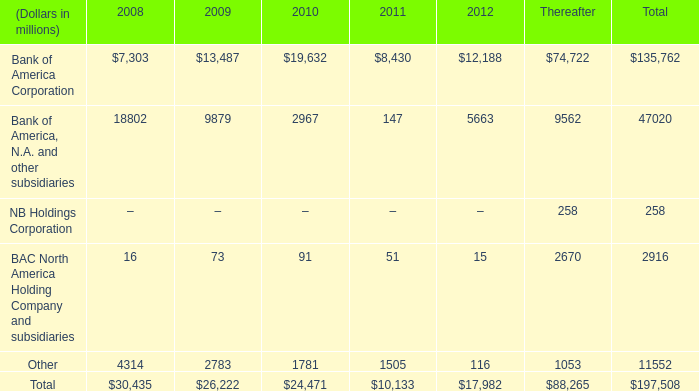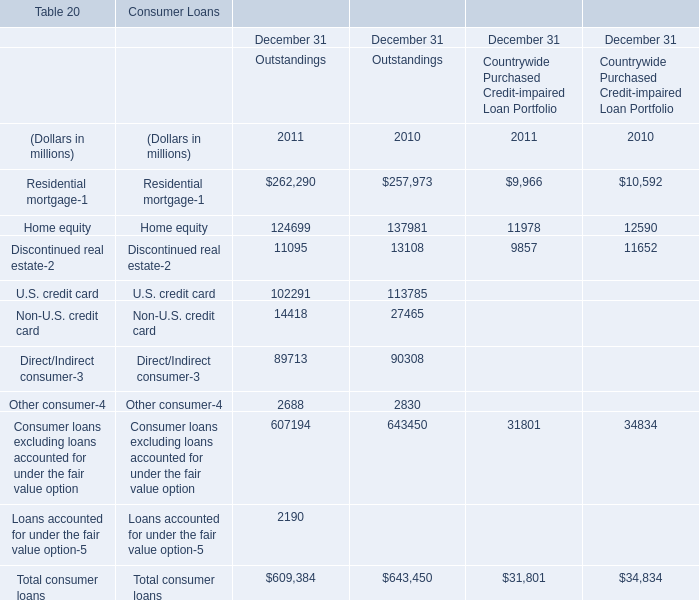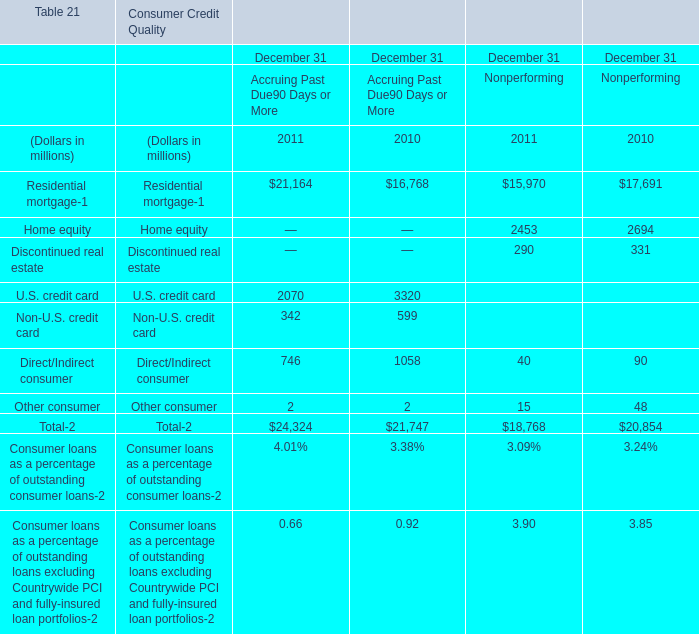What was the average value of the Home equity in the years where Residential mortgage- is positive? (in million) 
Computations: ((124699 + 137981) / 2)
Answer: 131340.0. 